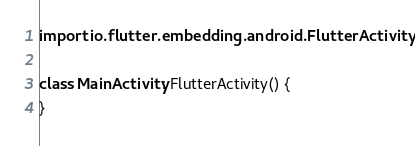Convert code to text. <code><loc_0><loc_0><loc_500><loc_500><_Kotlin_>import io.flutter.embedding.android.FlutterActivity

class MainActivity: FlutterActivity() {
}
</code> 